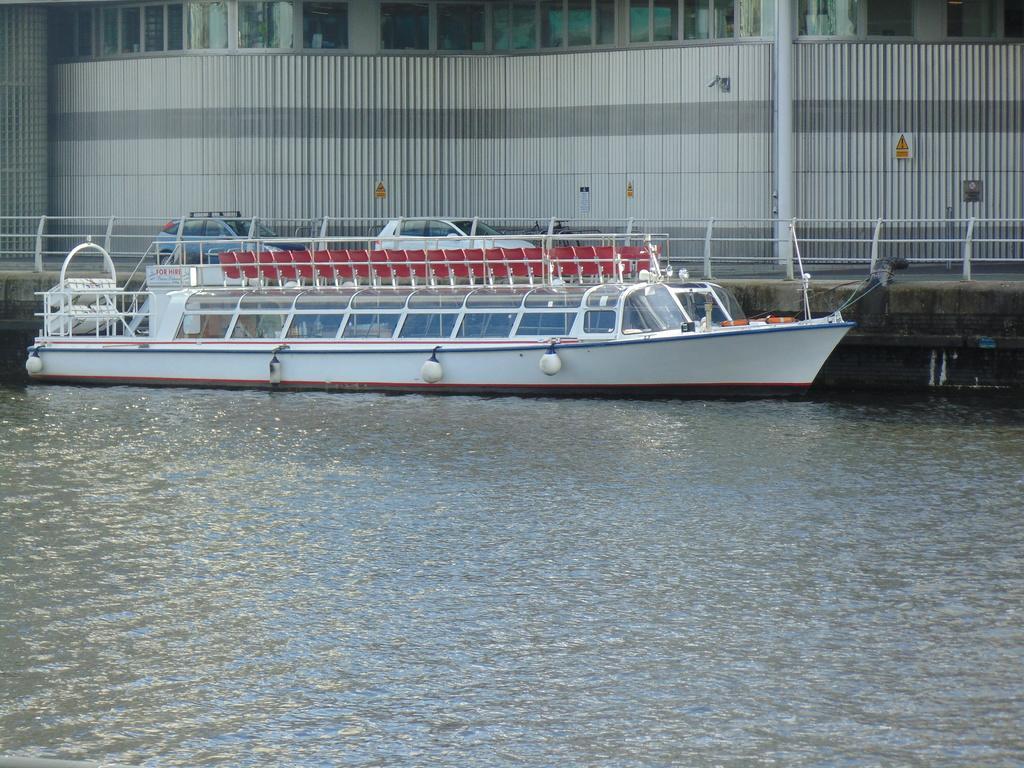Could you give a brief overview of what you see in this image? There is a boat on the water. Near to that there is a railing and cars on the road. In the background there is a building and a pole is near to the building. And some sign boards are on the building. 